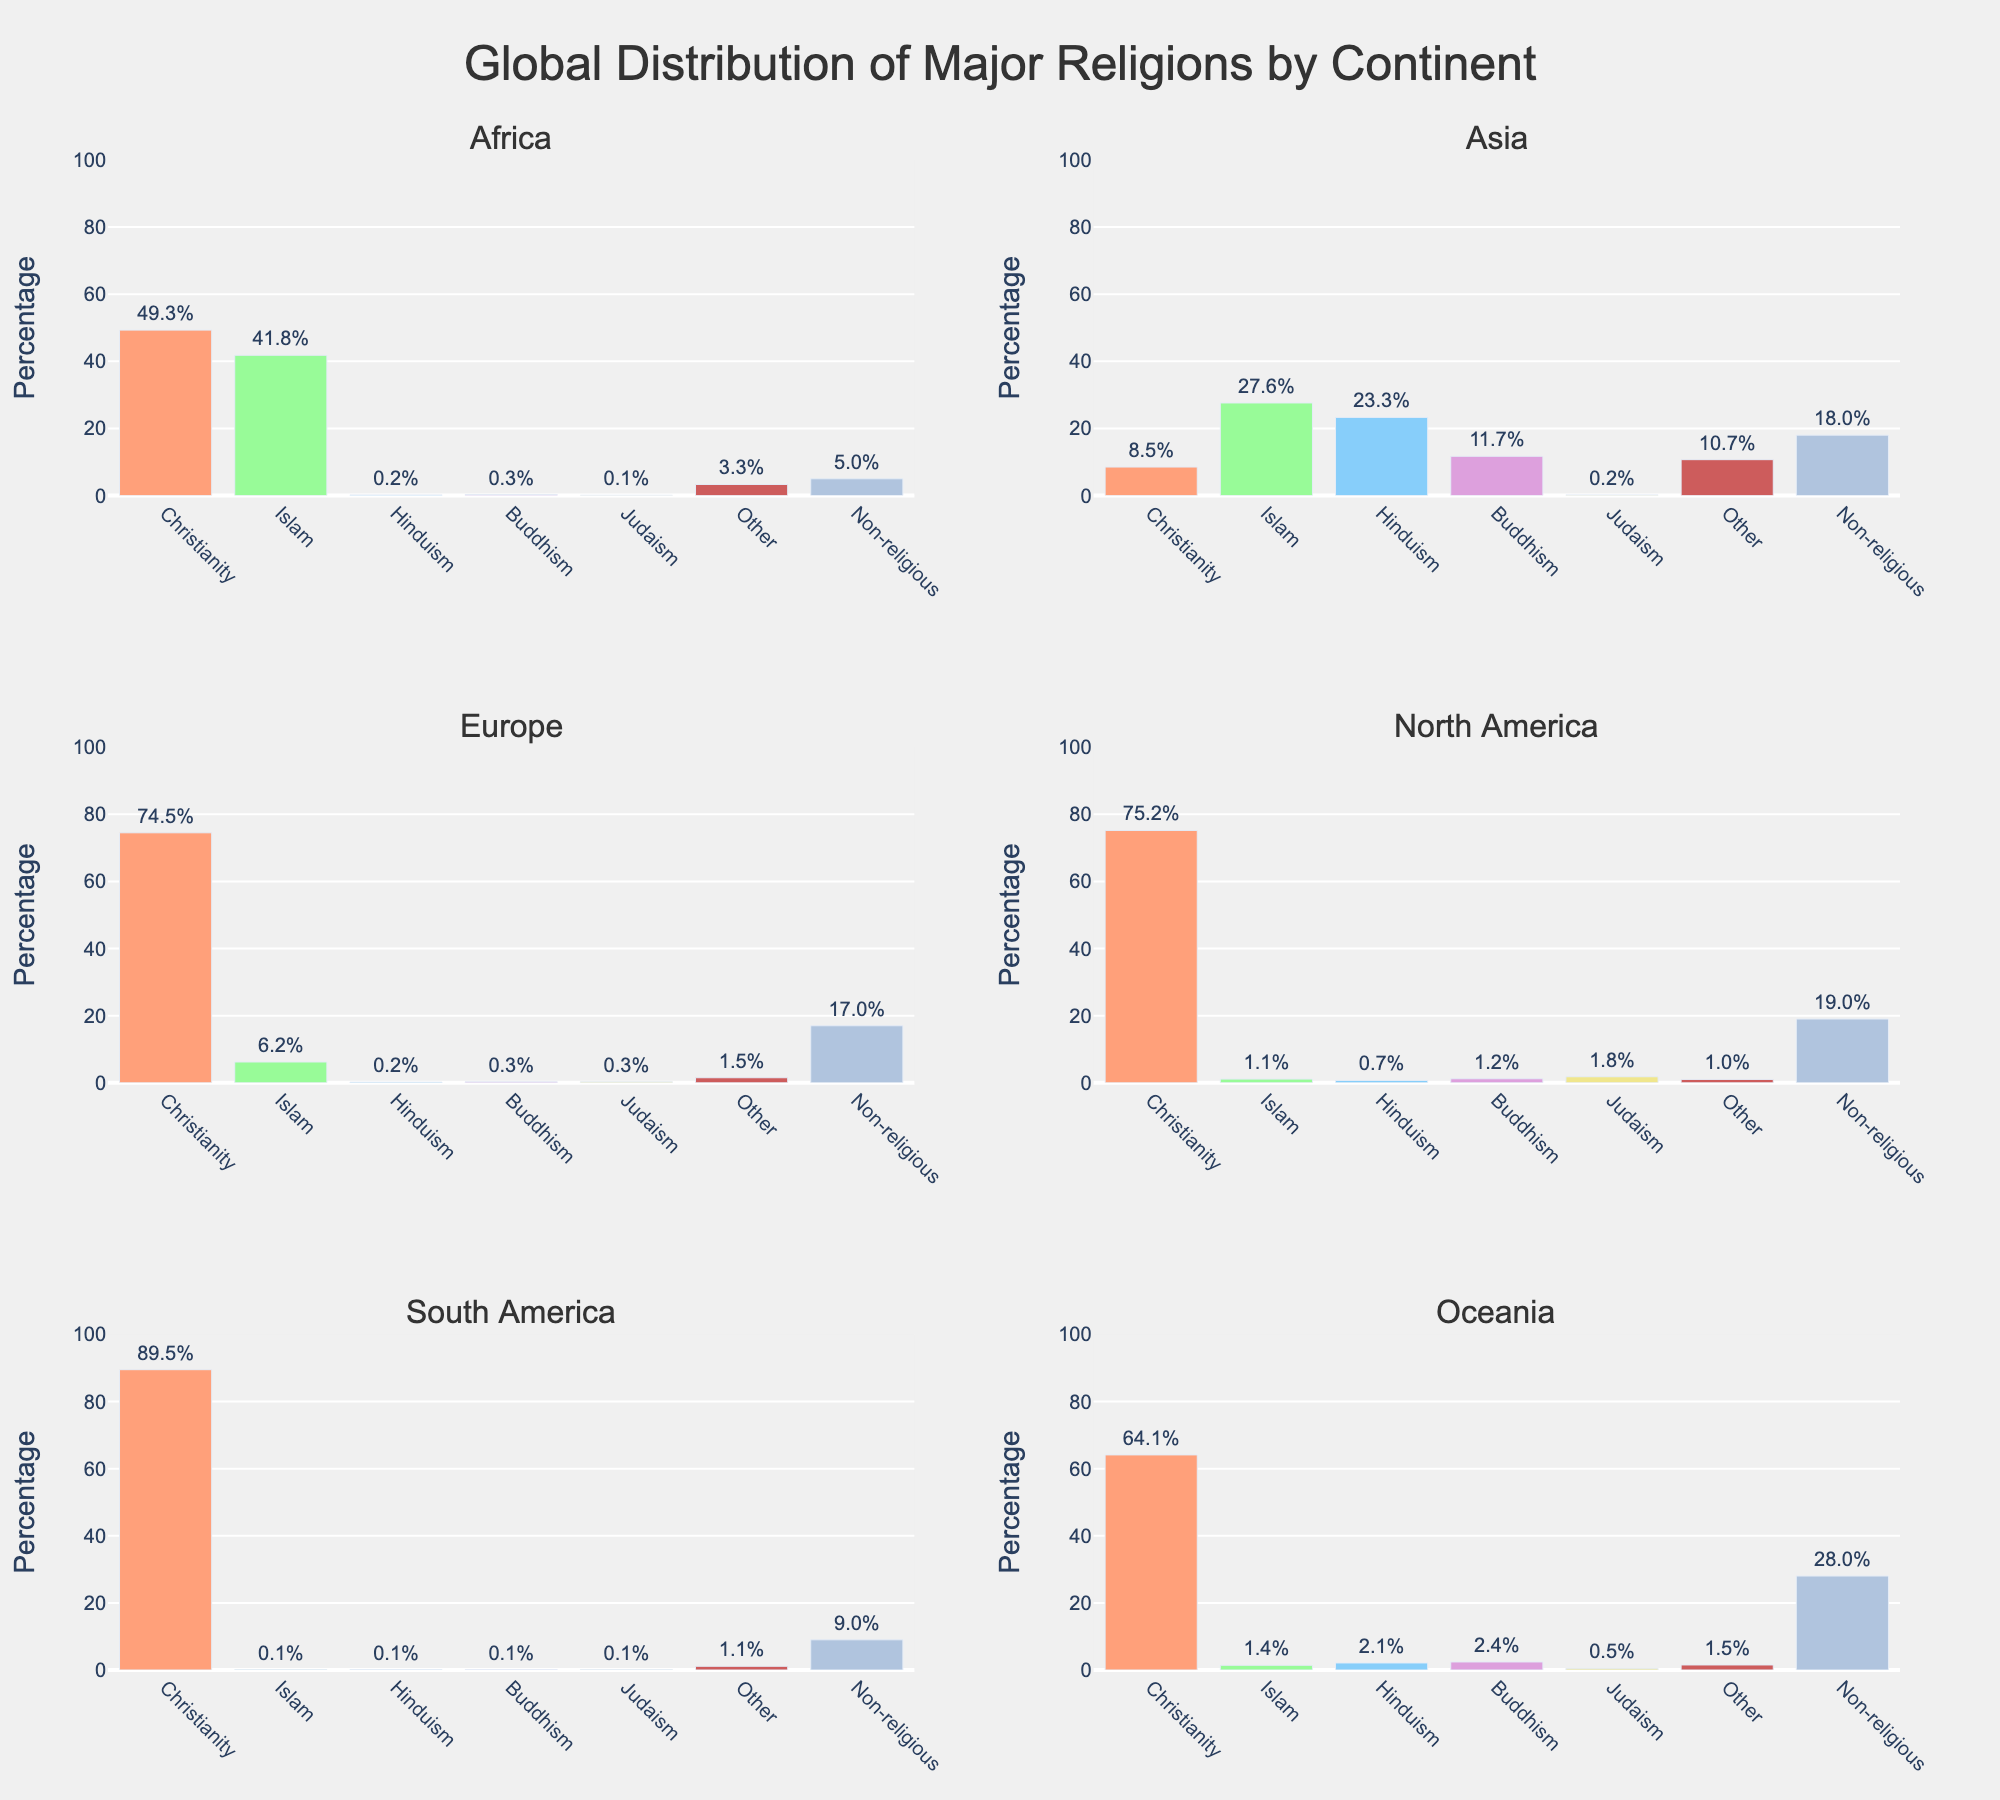Which continent has the highest percentage of Christians? Looking at the subplots, South America shows the highest bar for Christianity, indicating it has the highest percentage.
Answer: South America Which continent shows the highest percentage of non-religious people? Checking the subplot bars for the 'Non-religious' category, Oceania shows the tallest bar indicating it has the highest percentage.
Answer: Oceania What is the combined percentage of Islam and Hinduism in Asia? In the subplot for Asia, the bar for Islam is at 27.6%, and Hinduism is at 23.3%. Adding these two percentages gives 27.6 + 23.3 = 50.9%.
Answer: 50.9% Which religion has the least representation in North America? Referring to the subplot for North America, Hinduism has the smallest bar at 0.7%.
Answer: Hinduism Compare the percentage of Buddhism in Asia and Oceania. Which one is higher? Observing the subplots for Asia and Oceania, the bar for Buddhism in Asia is at 11.7% while for Oceania it is at 2.4%. Therefore, Asia has a higher percentage of Buddhists.
Answer: Asia What is the difference in the percentage of Judaism between Europe and Africa? The subplot for Europe shows Judaism at 0.3%, and for Africa, it is at 0.1%. The difference is 0.3% - 0.1% = 0.2%.
Answer: 0.2% What are the top two religions in Africa? In the subplot for Africa, the tallest bars represent Christianity (49.3%) and Islam (41.8%).
Answer: Christianity and Islam Which continent has the widest variety of religious representation? By counting the significant bars in each subplot, Asia shows representation across all religions, making it the continent with the widest variety.
Answer: Asia What is the average percentage of the 'Other' category across all continents? Summing the 'Other' percentages from each continent: 3.3 + 10.7 + 1.5 + 1.0 + 1.1 + 1.5 = 19.1%. The average across the 6 continents is 19.1/6 = 3.2%.
Answer: 3.2% 